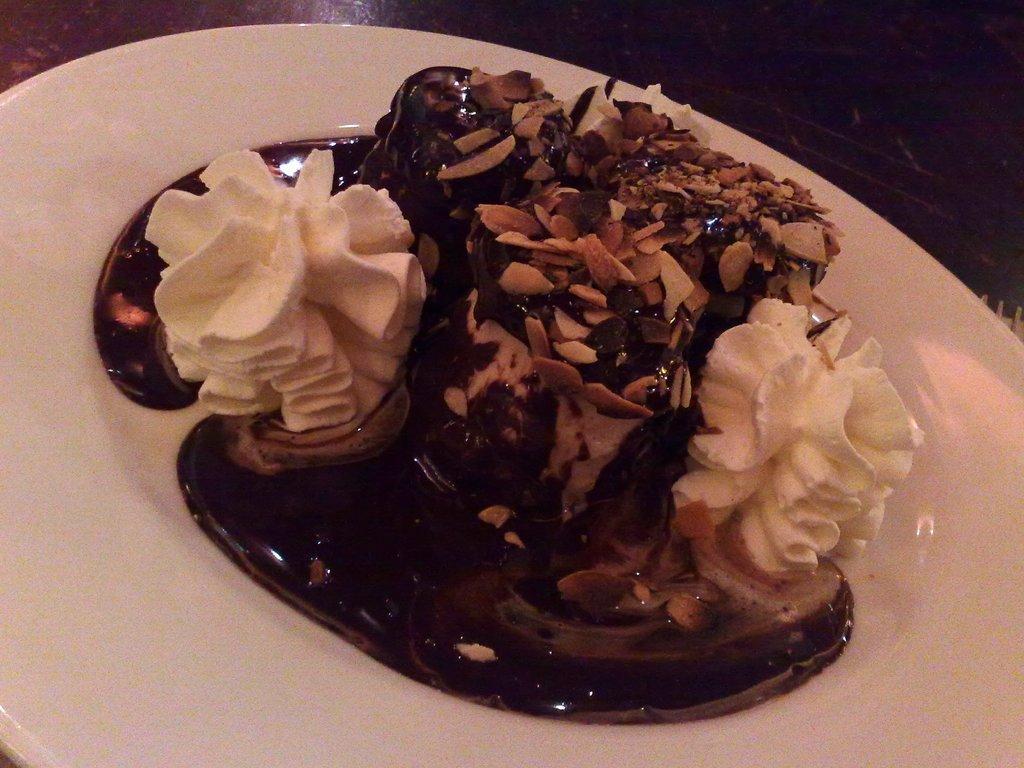Can you describe this image briefly? In this image there is a white plate on which there is a cake. On the cake there is cream, and some dry fruits. 